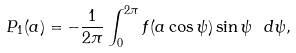<formula> <loc_0><loc_0><loc_500><loc_500>P _ { 1 } ( a ) = - \frac { 1 } { 2 \pi } \int _ { 0 } ^ { 2 \pi } f ( a \cos \psi ) \sin \psi \ d \psi ,</formula> 